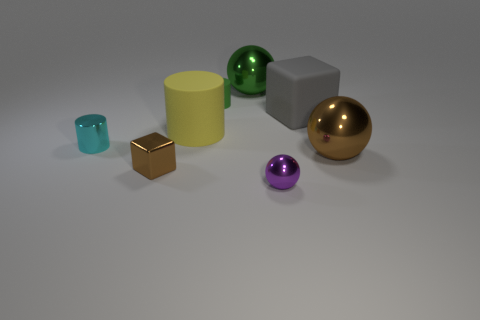Add 2 large green rubber objects. How many objects exist? 10 Subtract all blocks. How many objects are left? 6 Subtract 0 red balls. How many objects are left? 8 Subtract all big green rubber cylinders. Subtract all tiny cyan things. How many objects are left? 7 Add 4 large green shiny spheres. How many large green shiny spheres are left? 5 Add 6 blue rubber things. How many blue rubber things exist? 6 